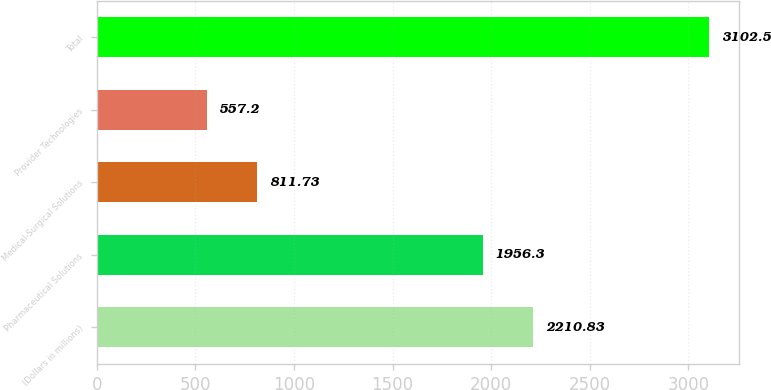<chart> <loc_0><loc_0><loc_500><loc_500><bar_chart><fcel>(Dollars in millions)<fcel>Pharmaceutical Solutions<fcel>Medical-Surgical Solutions<fcel>Provider Technologies<fcel>Total<nl><fcel>2210.83<fcel>1956.3<fcel>811.73<fcel>557.2<fcel>3102.5<nl></chart> 